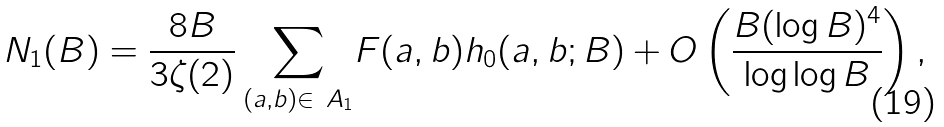<formula> <loc_0><loc_0><loc_500><loc_500>N _ { 1 } ( B ) = \frac { 8 B } { 3 \zeta ( 2 ) } \sum _ { ( a , b ) \in \ A _ { 1 } } & F ( a , b ) h _ { 0 } ( a , b ; B ) + O \left ( \frac { B ( \log B ) ^ { 4 } } { \log \log B } \right ) ,</formula> 